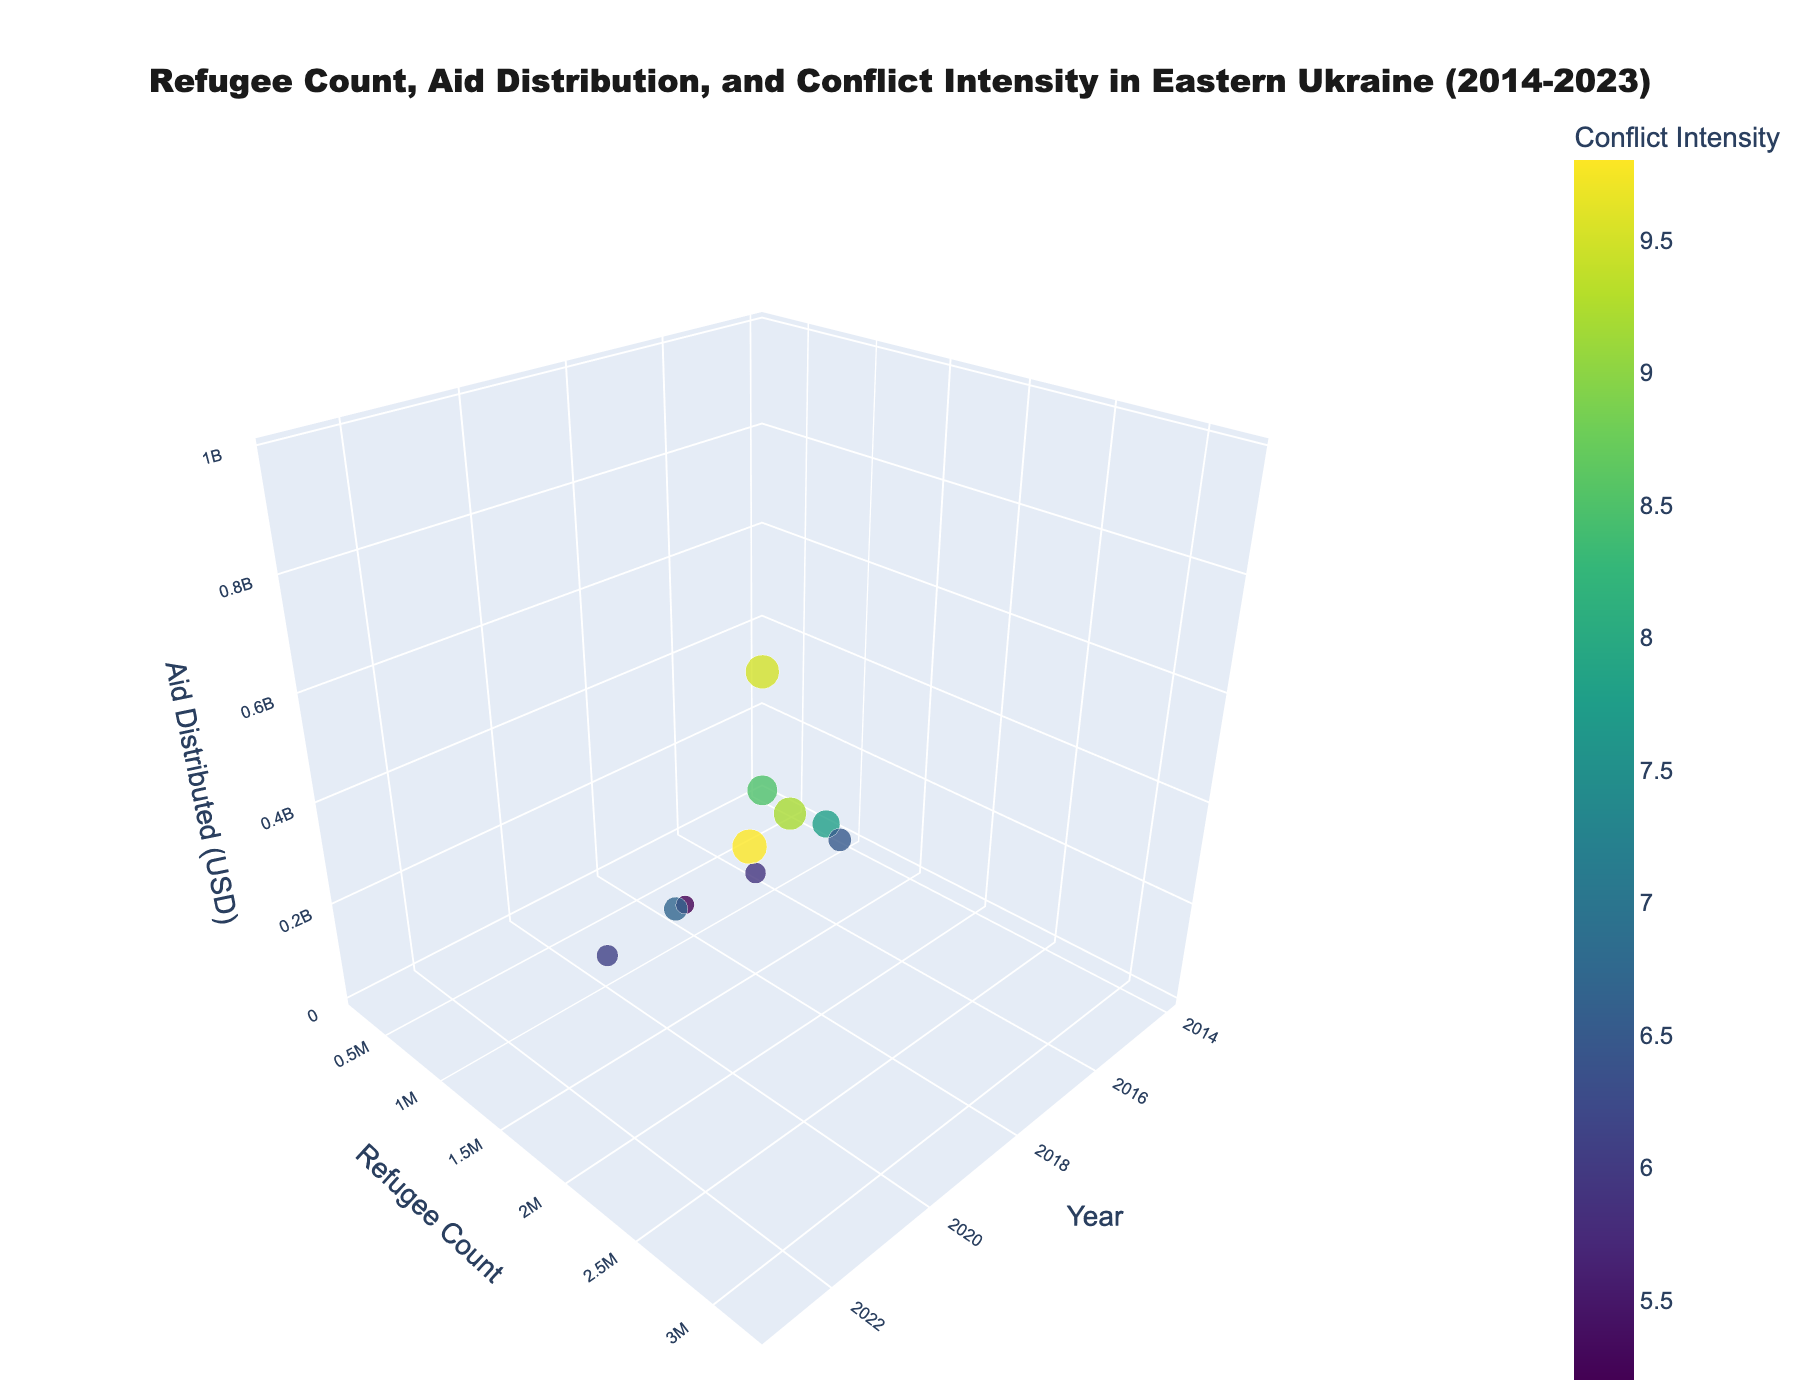How many data points are shown in the figure? The figure shows one data point for each year from 2014 to 2023. Counting these gives us 10 data points.
Answer: 10 What is the title of the figure? The title of the figure is displayed at the top center of the plot. It reads, "Refugee Count, Aid Distribution, and Conflict Intensity in Eastern Ukraine (2014-2023)."
Answer: Refugee Count, Aid Distribution, and Conflict Intensity in Eastern Ukraine (2014-2023) Which year had the highest refugee count? By examining the y-axis labeled "Refugee Count" and the markers representing each year, we see that the highest refugee count is marked around the year 2023. From the hover text, "Year: 2023<br>Refugees: 3,200,000," this confirms 2023 had the highest refugee count.
Answer: 2023 Compare the conflict intensities in 2014 and 2016. Which year had a higher conflict intensity? Conflict Intensity is represented by the color and size of the markers. The hover text for 2014 shows a conflict intensity of 8.5, while 2016 shows 7.8. Therefore, 2014 had a higher conflict intensity.
Answer: 2014 What's the total amount of humanitarian aid distributed across all years? Adding the amount of aid distributed in each year: 15,000,000 + 85,000,000 + 195,000,000 + 268,000,000 + 204,000,000 + 158,000,000 + 252,000,000 + 189,000,000 + 650,000,000 + 980,000,000 gives a total of 2,996,000,000 USD.
Answer: 2,996,000,000 USD How does the aid distributed in 2017 compare to that in 2019? The aid distributed in 2017 is 268,000,000 USD, and in 2019, it is 158,000,000 USD. Therefore, the aid in 2017 is higher than that in 2019 by 110,000,000 USD.
Answer: Aid in 2017 is higher by 110,000,000 USD Which year had the lowest conflict intensity and what was the refugee count in that year? The smallest marker and lowest color intensity indicate the lowest conflict intensity, which is in 2019 with a value of 5.2. The refugee count for that year, as shown in the vertical position on the y-axis and the hover text, is 1,300,000.
Answer: 2019, 1,300,000 What is the trend of conflict intensity from 2014 to 2018? Observing the color and size of the markers from 2014 to 2018, the conflict intensity decreases over these years. 2014 starts at 8.5 and progressively reduces each year, reaching 5.9 in 2018.
Answer: Decreasing trend Calculate the average refugee count from 2014 to 2016. Adding the refugee counts for 2014, 2015, and 2016: 231,000 + 800,000 + 1,400,000 = 2,431,000. Dividing by the 3 years gives an average of 810,333 (rounded to the nearest whole number).
Answer: 810,333 In 2023, how does the amount of aid distributed correlate with conflict intensity? Observing the marker for 2023, it is large and dark indicating high conflict intensity (9.5) and high aid distributed (980,000,000 USD). This suggests a positive correlation where higher conflict intensity leads to higher aid distribution.
Answer: Positive correlation 